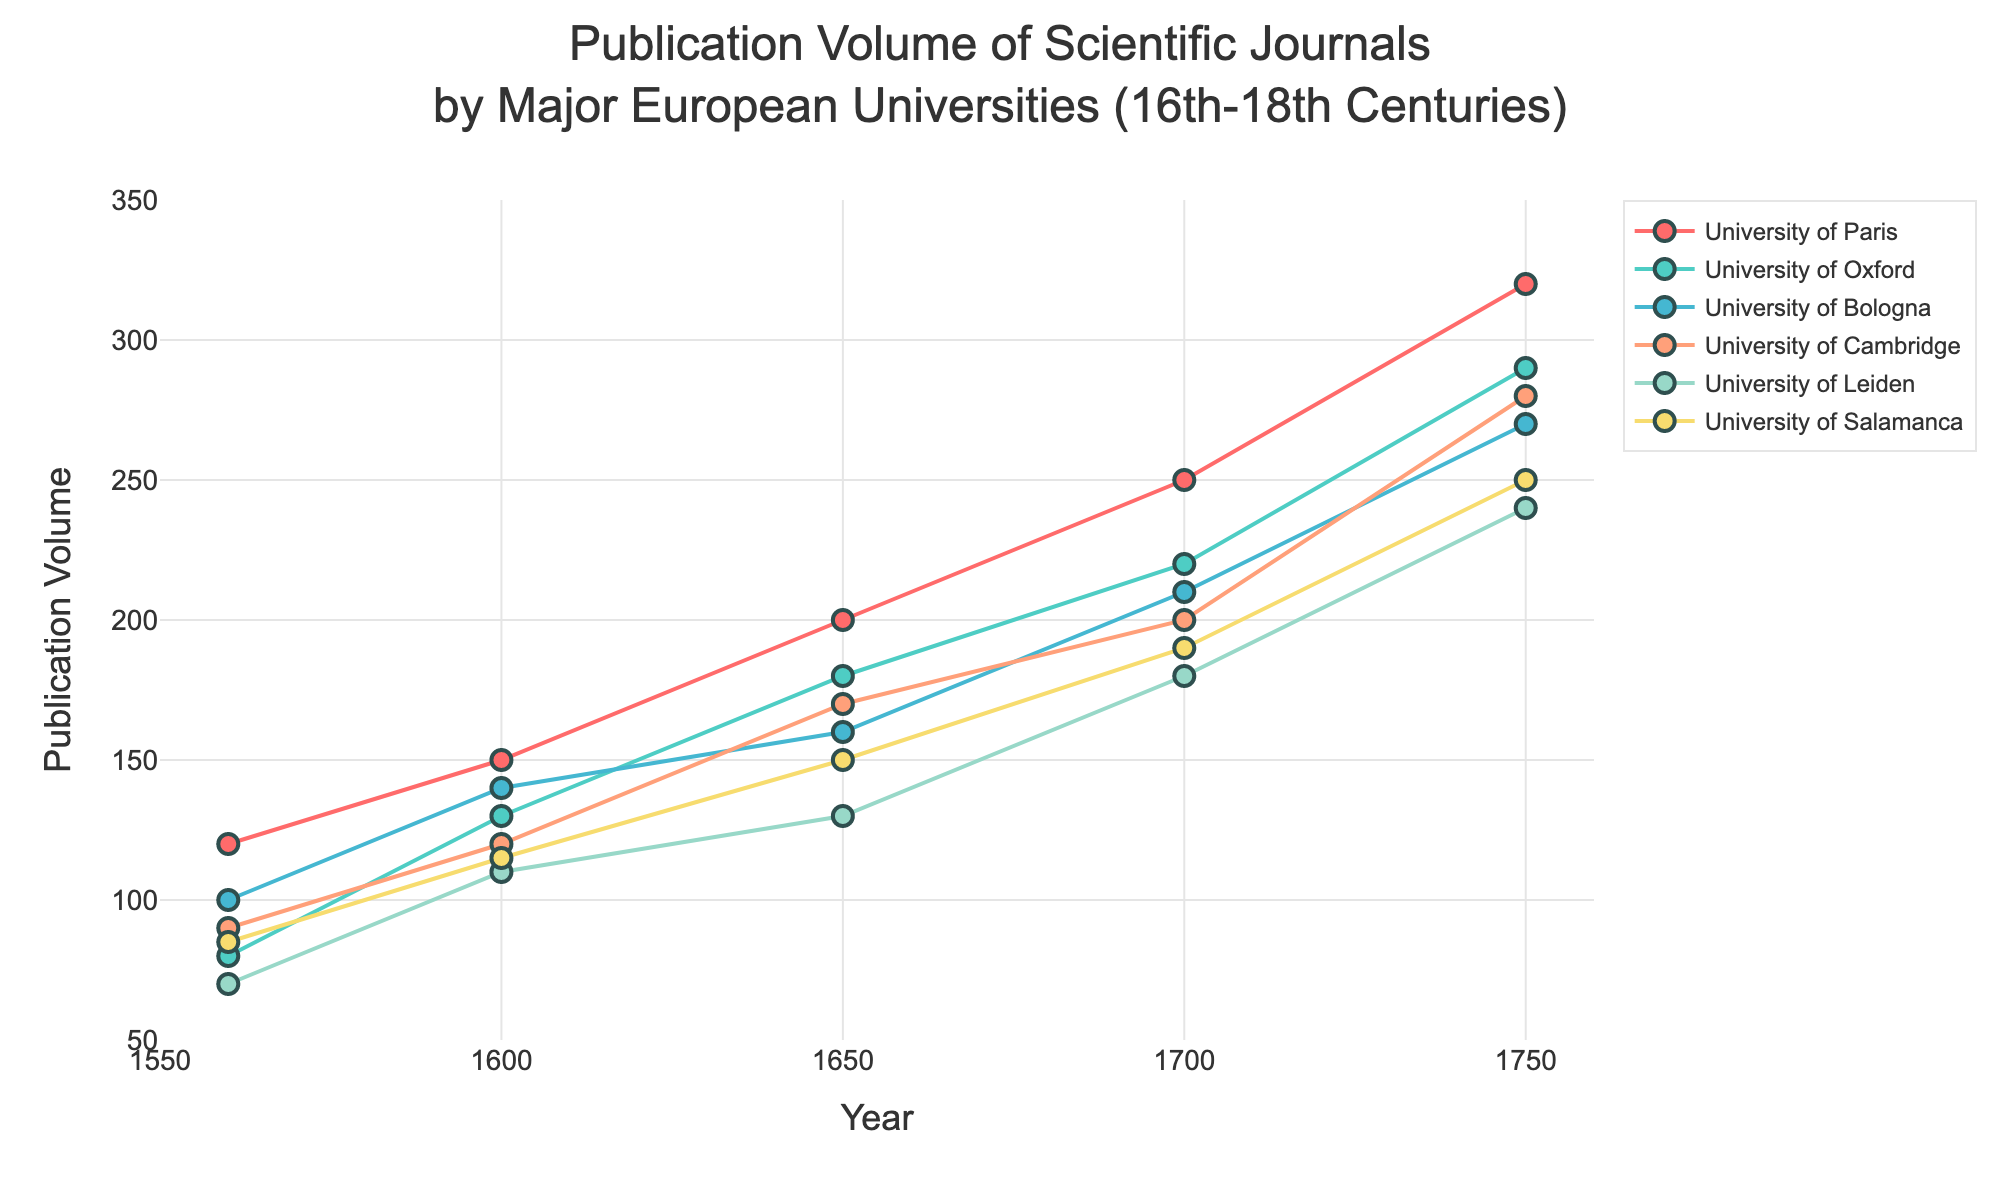What is the publication volume for the University of Paris in 1750? Look at the data point for the University of Paris in the year 1750 on the plot and check the corresponding publication volume.
Answer: 320 Which university had the highest publication volume in 1600? Compare the data points for all universities in the year 1600 and identify the one with the highest publication volume.
Answer: University of Paris How did the publication volume of the University of Oxford change from 1560 to 1750? Refer to the University of Oxford's data points from 1560 to 1750 and subtract the publication volume in 1560 from that in 1750 (290 - 80).
Answer: Increased by 210 Which university experienced the greatest increase in publication volume between 1650 and 1700? Calculate the differences in publication volumes for each university between 1650 and 1700 and find the university with the largest increase.
Answer: University of Bologna What is the average publication volume for the University of Cambridge across all years? Sum the publication volumes for the University of Cambridge and divide by the number of years (90+120+170+200+280)/5.
Answer: 172 Which two universities had the closest publication volumes in 1750? Compare the publication volumes of all universities in 1750 and find the pair with the smallest difference.
Answer: University of Paris and University of Salamanca What is the overall trend in publication volumes for the University of Leiden from 1560 to 1750? Observe the University of Leiden's data points from 1560 to 1750 and see if they generally increase, decrease, or remain stable over time.
Answer: Increasing How many universities had a higher publication volume in 1700 compared to 1650? Compare the publication volumes of all universities in 1650 and 1700 and count those that increased.
Answer: 6 Which university had the most consistent growth in publication volume over the centuries? Analyze the lines representing each university and determine which line shows the most uniform increase.
Answer: University of Bologna Did any university have a publication volume decrease between any two consecutive periods? Inspect each university's data points for any two consecutive time periods to see if there is a drop in publication volume.
Answer: No 